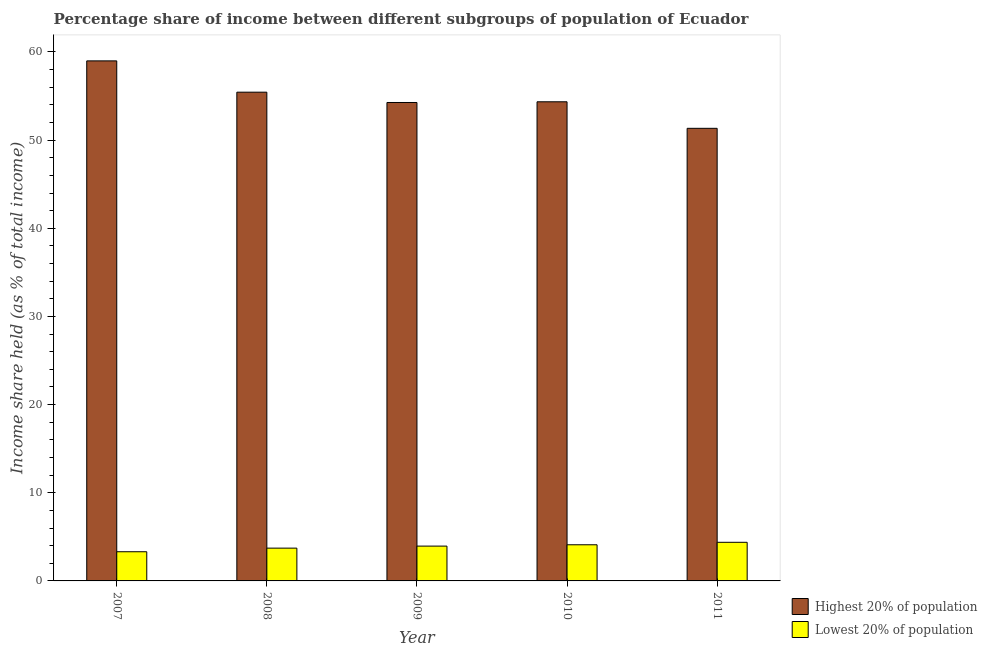How many different coloured bars are there?
Ensure brevity in your answer.  2. How many groups of bars are there?
Your response must be concise. 5. Are the number of bars per tick equal to the number of legend labels?
Offer a terse response. Yes. How many bars are there on the 3rd tick from the left?
Make the answer very short. 2. How many bars are there on the 3rd tick from the right?
Offer a very short reply. 2. What is the income share held by highest 20% of the population in 2011?
Offer a terse response. 51.34. Across all years, what is the maximum income share held by highest 20% of the population?
Offer a very short reply. 58.99. Across all years, what is the minimum income share held by highest 20% of the population?
Keep it short and to the point. 51.34. In which year was the income share held by highest 20% of the population minimum?
Ensure brevity in your answer.  2011. What is the total income share held by lowest 20% of the population in the graph?
Your answer should be compact. 19.46. What is the difference between the income share held by lowest 20% of the population in 2007 and that in 2010?
Provide a short and direct response. -0.79. What is the difference between the income share held by lowest 20% of the population in 2008 and the income share held by highest 20% of the population in 2010?
Offer a very short reply. -0.38. What is the average income share held by lowest 20% of the population per year?
Make the answer very short. 3.89. In the year 2008, what is the difference between the income share held by highest 20% of the population and income share held by lowest 20% of the population?
Provide a succinct answer. 0. In how many years, is the income share held by highest 20% of the population greater than 48 %?
Make the answer very short. 5. What is the ratio of the income share held by highest 20% of the population in 2008 to that in 2009?
Make the answer very short. 1.02. Is the difference between the income share held by lowest 20% of the population in 2008 and 2011 greater than the difference between the income share held by highest 20% of the population in 2008 and 2011?
Provide a short and direct response. No. What is the difference between the highest and the second highest income share held by highest 20% of the population?
Offer a very short reply. 3.55. What is the difference between the highest and the lowest income share held by lowest 20% of the population?
Provide a succinct answer. 1.07. In how many years, is the income share held by lowest 20% of the population greater than the average income share held by lowest 20% of the population taken over all years?
Your answer should be compact. 3. Is the sum of the income share held by highest 20% of the population in 2007 and 2010 greater than the maximum income share held by lowest 20% of the population across all years?
Offer a very short reply. Yes. What does the 2nd bar from the left in 2011 represents?
Provide a succinct answer. Lowest 20% of population. What does the 2nd bar from the right in 2009 represents?
Offer a terse response. Highest 20% of population. How many bars are there?
Keep it short and to the point. 10. Are all the bars in the graph horizontal?
Your answer should be very brief. No. How many legend labels are there?
Your response must be concise. 2. What is the title of the graph?
Offer a very short reply. Percentage share of income between different subgroups of population of Ecuador. Does "Private credit bureau" appear as one of the legend labels in the graph?
Offer a terse response. No. What is the label or title of the X-axis?
Provide a short and direct response. Year. What is the label or title of the Y-axis?
Ensure brevity in your answer.  Income share held (as % of total income). What is the Income share held (as % of total income) in Highest 20% of population in 2007?
Your answer should be very brief. 58.99. What is the Income share held (as % of total income) of Lowest 20% of population in 2007?
Provide a short and direct response. 3.31. What is the Income share held (as % of total income) in Highest 20% of population in 2008?
Provide a short and direct response. 55.44. What is the Income share held (as % of total income) in Lowest 20% of population in 2008?
Give a very brief answer. 3.72. What is the Income share held (as % of total income) of Highest 20% of population in 2009?
Offer a terse response. 54.27. What is the Income share held (as % of total income) in Lowest 20% of population in 2009?
Your answer should be compact. 3.95. What is the Income share held (as % of total income) of Highest 20% of population in 2010?
Provide a succinct answer. 54.35. What is the Income share held (as % of total income) of Highest 20% of population in 2011?
Your answer should be compact. 51.34. What is the Income share held (as % of total income) in Lowest 20% of population in 2011?
Provide a short and direct response. 4.38. Across all years, what is the maximum Income share held (as % of total income) of Highest 20% of population?
Keep it short and to the point. 58.99. Across all years, what is the maximum Income share held (as % of total income) in Lowest 20% of population?
Give a very brief answer. 4.38. Across all years, what is the minimum Income share held (as % of total income) in Highest 20% of population?
Keep it short and to the point. 51.34. Across all years, what is the minimum Income share held (as % of total income) in Lowest 20% of population?
Offer a terse response. 3.31. What is the total Income share held (as % of total income) in Highest 20% of population in the graph?
Provide a succinct answer. 274.39. What is the total Income share held (as % of total income) of Lowest 20% of population in the graph?
Give a very brief answer. 19.46. What is the difference between the Income share held (as % of total income) in Highest 20% of population in 2007 and that in 2008?
Your response must be concise. 3.55. What is the difference between the Income share held (as % of total income) in Lowest 20% of population in 2007 and that in 2008?
Offer a terse response. -0.41. What is the difference between the Income share held (as % of total income) in Highest 20% of population in 2007 and that in 2009?
Provide a short and direct response. 4.72. What is the difference between the Income share held (as % of total income) of Lowest 20% of population in 2007 and that in 2009?
Your answer should be very brief. -0.64. What is the difference between the Income share held (as % of total income) of Highest 20% of population in 2007 and that in 2010?
Your answer should be very brief. 4.64. What is the difference between the Income share held (as % of total income) in Lowest 20% of population in 2007 and that in 2010?
Provide a succinct answer. -0.79. What is the difference between the Income share held (as % of total income) in Highest 20% of population in 2007 and that in 2011?
Offer a terse response. 7.65. What is the difference between the Income share held (as % of total income) of Lowest 20% of population in 2007 and that in 2011?
Your answer should be compact. -1.07. What is the difference between the Income share held (as % of total income) of Highest 20% of population in 2008 and that in 2009?
Provide a succinct answer. 1.17. What is the difference between the Income share held (as % of total income) of Lowest 20% of population in 2008 and that in 2009?
Your response must be concise. -0.23. What is the difference between the Income share held (as % of total income) in Highest 20% of population in 2008 and that in 2010?
Make the answer very short. 1.09. What is the difference between the Income share held (as % of total income) of Lowest 20% of population in 2008 and that in 2010?
Provide a succinct answer. -0.38. What is the difference between the Income share held (as % of total income) in Highest 20% of population in 2008 and that in 2011?
Make the answer very short. 4.1. What is the difference between the Income share held (as % of total income) in Lowest 20% of population in 2008 and that in 2011?
Give a very brief answer. -0.66. What is the difference between the Income share held (as % of total income) in Highest 20% of population in 2009 and that in 2010?
Ensure brevity in your answer.  -0.08. What is the difference between the Income share held (as % of total income) in Lowest 20% of population in 2009 and that in 2010?
Provide a short and direct response. -0.15. What is the difference between the Income share held (as % of total income) of Highest 20% of population in 2009 and that in 2011?
Provide a short and direct response. 2.93. What is the difference between the Income share held (as % of total income) of Lowest 20% of population in 2009 and that in 2011?
Ensure brevity in your answer.  -0.43. What is the difference between the Income share held (as % of total income) in Highest 20% of population in 2010 and that in 2011?
Offer a very short reply. 3.01. What is the difference between the Income share held (as % of total income) of Lowest 20% of population in 2010 and that in 2011?
Offer a very short reply. -0.28. What is the difference between the Income share held (as % of total income) of Highest 20% of population in 2007 and the Income share held (as % of total income) of Lowest 20% of population in 2008?
Ensure brevity in your answer.  55.27. What is the difference between the Income share held (as % of total income) of Highest 20% of population in 2007 and the Income share held (as % of total income) of Lowest 20% of population in 2009?
Give a very brief answer. 55.04. What is the difference between the Income share held (as % of total income) of Highest 20% of population in 2007 and the Income share held (as % of total income) of Lowest 20% of population in 2010?
Provide a succinct answer. 54.89. What is the difference between the Income share held (as % of total income) of Highest 20% of population in 2007 and the Income share held (as % of total income) of Lowest 20% of population in 2011?
Offer a very short reply. 54.61. What is the difference between the Income share held (as % of total income) of Highest 20% of population in 2008 and the Income share held (as % of total income) of Lowest 20% of population in 2009?
Your response must be concise. 51.49. What is the difference between the Income share held (as % of total income) of Highest 20% of population in 2008 and the Income share held (as % of total income) of Lowest 20% of population in 2010?
Your answer should be very brief. 51.34. What is the difference between the Income share held (as % of total income) in Highest 20% of population in 2008 and the Income share held (as % of total income) in Lowest 20% of population in 2011?
Offer a terse response. 51.06. What is the difference between the Income share held (as % of total income) in Highest 20% of population in 2009 and the Income share held (as % of total income) in Lowest 20% of population in 2010?
Give a very brief answer. 50.17. What is the difference between the Income share held (as % of total income) in Highest 20% of population in 2009 and the Income share held (as % of total income) in Lowest 20% of population in 2011?
Make the answer very short. 49.89. What is the difference between the Income share held (as % of total income) in Highest 20% of population in 2010 and the Income share held (as % of total income) in Lowest 20% of population in 2011?
Offer a very short reply. 49.97. What is the average Income share held (as % of total income) of Highest 20% of population per year?
Offer a terse response. 54.88. What is the average Income share held (as % of total income) of Lowest 20% of population per year?
Ensure brevity in your answer.  3.89. In the year 2007, what is the difference between the Income share held (as % of total income) in Highest 20% of population and Income share held (as % of total income) in Lowest 20% of population?
Provide a succinct answer. 55.68. In the year 2008, what is the difference between the Income share held (as % of total income) in Highest 20% of population and Income share held (as % of total income) in Lowest 20% of population?
Your answer should be very brief. 51.72. In the year 2009, what is the difference between the Income share held (as % of total income) in Highest 20% of population and Income share held (as % of total income) in Lowest 20% of population?
Your response must be concise. 50.32. In the year 2010, what is the difference between the Income share held (as % of total income) in Highest 20% of population and Income share held (as % of total income) in Lowest 20% of population?
Keep it short and to the point. 50.25. In the year 2011, what is the difference between the Income share held (as % of total income) in Highest 20% of population and Income share held (as % of total income) in Lowest 20% of population?
Your response must be concise. 46.96. What is the ratio of the Income share held (as % of total income) in Highest 20% of population in 2007 to that in 2008?
Your answer should be compact. 1.06. What is the ratio of the Income share held (as % of total income) of Lowest 20% of population in 2007 to that in 2008?
Give a very brief answer. 0.89. What is the ratio of the Income share held (as % of total income) in Highest 20% of population in 2007 to that in 2009?
Your response must be concise. 1.09. What is the ratio of the Income share held (as % of total income) of Lowest 20% of population in 2007 to that in 2009?
Ensure brevity in your answer.  0.84. What is the ratio of the Income share held (as % of total income) of Highest 20% of population in 2007 to that in 2010?
Provide a succinct answer. 1.09. What is the ratio of the Income share held (as % of total income) of Lowest 20% of population in 2007 to that in 2010?
Provide a succinct answer. 0.81. What is the ratio of the Income share held (as % of total income) of Highest 20% of population in 2007 to that in 2011?
Keep it short and to the point. 1.15. What is the ratio of the Income share held (as % of total income) of Lowest 20% of population in 2007 to that in 2011?
Your response must be concise. 0.76. What is the ratio of the Income share held (as % of total income) of Highest 20% of population in 2008 to that in 2009?
Your answer should be very brief. 1.02. What is the ratio of the Income share held (as % of total income) of Lowest 20% of population in 2008 to that in 2009?
Make the answer very short. 0.94. What is the ratio of the Income share held (as % of total income) of Highest 20% of population in 2008 to that in 2010?
Offer a terse response. 1.02. What is the ratio of the Income share held (as % of total income) of Lowest 20% of population in 2008 to that in 2010?
Offer a terse response. 0.91. What is the ratio of the Income share held (as % of total income) in Highest 20% of population in 2008 to that in 2011?
Provide a succinct answer. 1.08. What is the ratio of the Income share held (as % of total income) in Lowest 20% of population in 2008 to that in 2011?
Make the answer very short. 0.85. What is the ratio of the Income share held (as % of total income) of Lowest 20% of population in 2009 to that in 2010?
Your answer should be compact. 0.96. What is the ratio of the Income share held (as % of total income) in Highest 20% of population in 2009 to that in 2011?
Your answer should be very brief. 1.06. What is the ratio of the Income share held (as % of total income) of Lowest 20% of population in 2009 to that in 2011?
Make the answer very short. 0.9. What is the ratio of the Income share held (as % of total income) in Highest 20% of population in 2010 to that in 2011?
Provide a short and direct response. 1.06. What is the ratio of the Income share held (as % of total income) in Lowest 20% of population in 2010 to that in 2011?
Make the answer very short. 0.94. What is the difference between the highest and the second highest Income share held (as % of total income) of Highest 20% of population?
Keep it short and to the point. 3.55. What is the difference between the highest and the second highest Income share held (as % of total income) of Lowest 20% of population?
Offer a terse response. 0.28. What is the difference between the highest and the lowest Income share held (as % of total income) of Highest 20% of population?
Offer a very short reply. 7.65. What is the difference between the highest and the lowest Income share held (as % of total income) of Lowest 20% of population?
Your response must be concise. 1.07. 